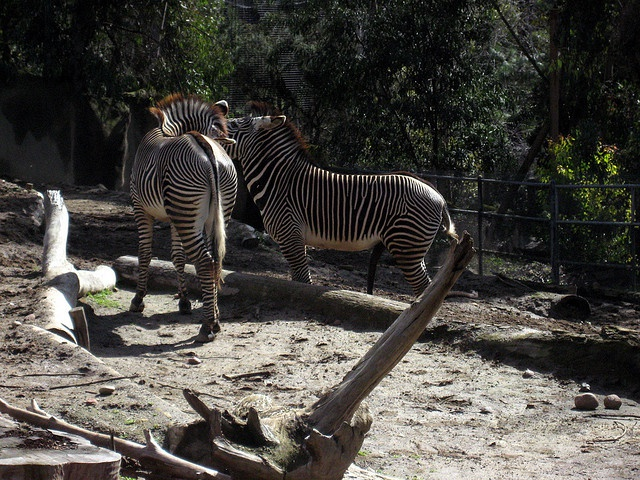Describe the objects in this image and their specific colors. I can see zebra in black and gray tones and zebra in black and gray tones in this image. 